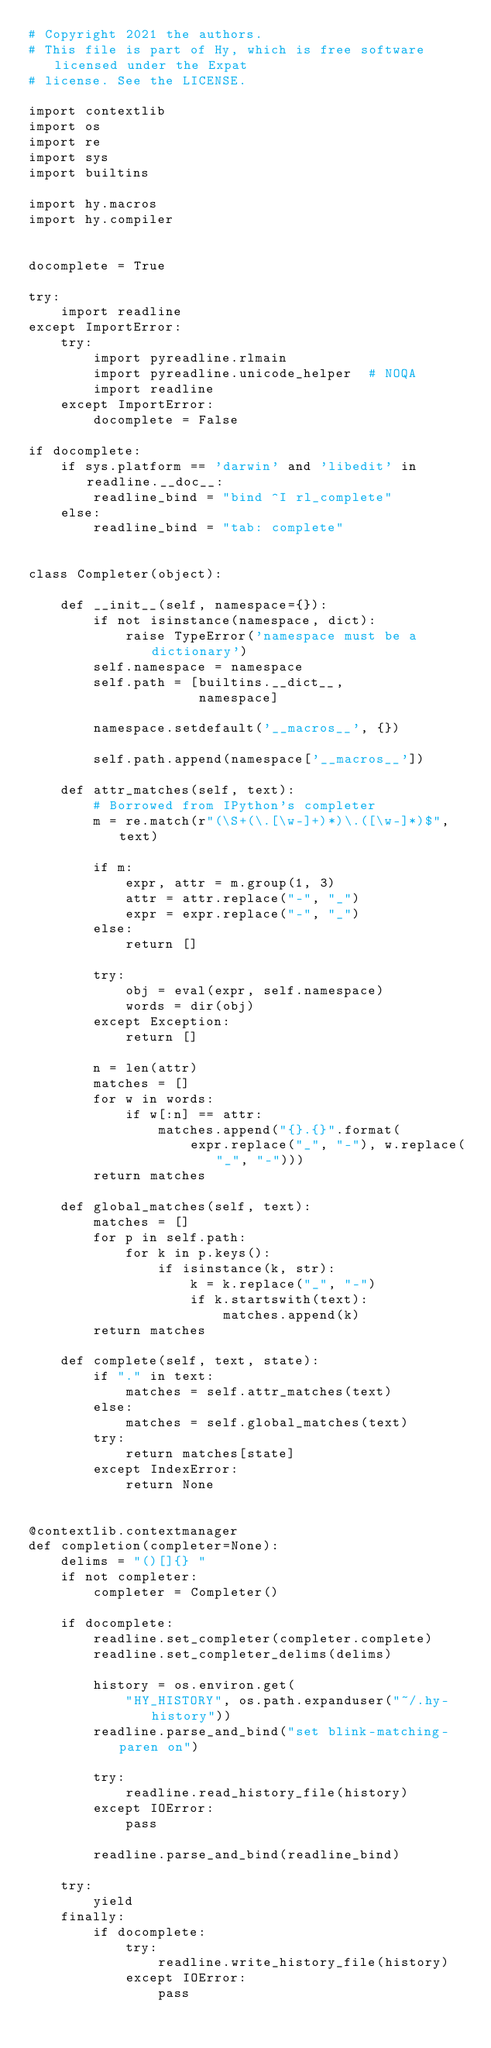Convert code to text. <code><loc_0><loc_0><loc_500><loc_500><_Python_># Copyright 2021 the authors.
# This file is part of Hy, which is free software licensed under the Expat
# license. See the LICENSE.

import contextlib
import os
import re
import sys
import builtins

import hy.macros
import hy.compiler


docomplete = True

try:
    import readline
except ImportError:
    try:
        import pyreadline.rlmain
        import pyreadline.unicode_helper  # NOQA
        import readline
    except ImportError:
        docomplete = False

if docomplete:
    if sys.platform == 'darwin' and 'libedit' in readline.__doc__:
        readline_bind = "bind ^I rl_complete"
    else:
        readline_bind = "tab: complete"


class Completer(object):

    def __init__(self, namespace={}):
        if not isinstance(namespace, dict):
            raise TypeError('namespace must be a dictionary')
        self.namespace = namespace
        self.path = [builtins.__dict__,
                     namespace]

        namespace.setdefault('__macros__', {})

        self.path.append(namespace['__macros__'])

    def attr_matches(self, text):
        # Borrowed from IPython's completer
        m = re.match(r"(\S+(\.[\w-]+)*)\.([\w-]*)$", text)

        if m:
            expr, attr = m.group(1, 3)
            attr = attr.replace("-", "_")
            expr = expr.replace("-", "_")
        else:
            return []

        try:
            obj = eval(expr, self.namespace)
            words = dir(obj)
        except Exception:
            return []

        n = len(attr)
        matches = []
        for w in words:
            if w[:n] == attr:
                matches.append("{}.{}".format(
                    expr.replace("_", "-"), w.replace("_", "-")))
        return matches

    def global_matches(self, text):
        matches = []
        for p in self.path:
            for k in p.keys():
                if isinstance(k, str):
                    k = k.replace("_", "-")
                    if k.startswith(text):
                        matches.append(k)
        return matches

    def complete(self, text, state):
        if "." in text:
            matches = self.attr_matches(text)
        else:
            matches = self.global_matches(text)
        try:
            return matches[state]
        except IndexError:
            return None


@contextlib.contextmanager
def completion(completer=None):
    delims = "()[]{} "
    if not completer:
        completer = Completer()

    if docomplete:
        readline.set_completer(completer.complete)
        readline.set_completer_delims(delims)

        history = os.environ.get(
            "HY_HISTORY", os.path.expanduser("~/.hy-history"))
        readline.parse_and_bind("set blink-matching-paren on")

        try:
            readline.read_history_file(history)
        except IOError:
            pass

        readline.parse_and_bind(readline_bind)

    try:
        yield
    finally:
        if docomplete:
            try:
                readline.write_history_file(history)
            except IOError:
                pass
</code> 